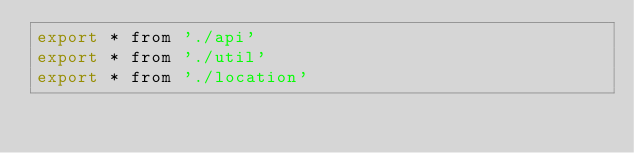Convert code to text. <code><loc_0><loc_0><loc_500><loc_500><_JavaScript_>export * from './api'
export * from './util'
export * from './location'
</code> 